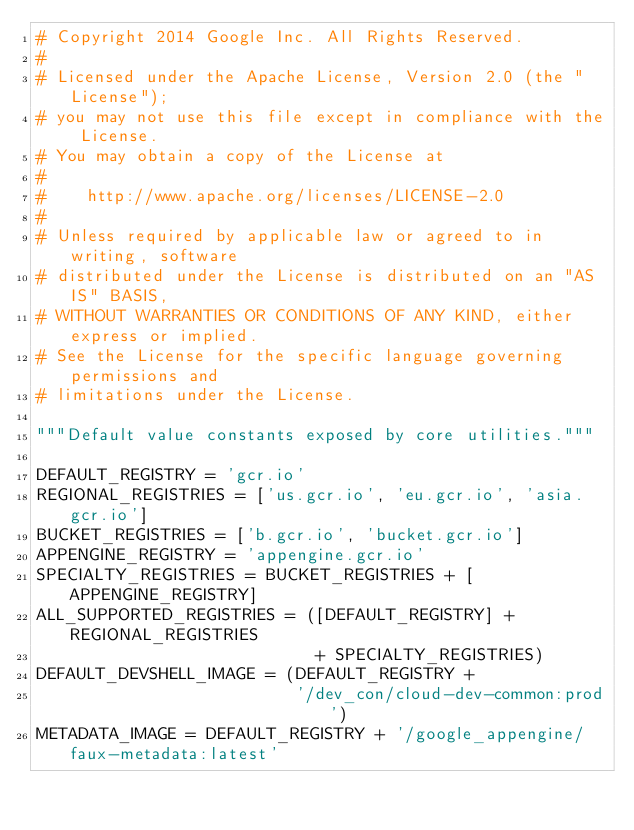<code> <loc_0><loc_0><loc_500><loc_500><_Python_># Copyright 2014 Google Inc. All Rights Reserved.
#
# Licensed under the Apache License, Version 2.0 (the "License");
# you may not use this file except in compliance with the License.
# You may obtain a copy of the License at
#
#    http://www.apache.org/licenses/LICENSE-2.0
#
# Unless required by applicable law or agreed to in writing, software
# distributed under the License is distributed on an "AS IS" BASIS,
# WITHOUT WARRANTIES OR CONDITIONS OF ANY KIND, either express or implied.
# See the License for the specific language governing permissions and
# limitations under the License.

"""Default value constants exposed by core utilities."""

DEFAULT_REGISTRY = 'gcr.io'
REGIONAL_REGISTRIES = ['us.gcr.io', 'eu.gcr.io', 'asia.gcr.io']
BUCKET_REGISTRIES = ['b.gcr.io', 'bucket.gcr.io']
APPENGINE_REGISTRY = 'appengine.gcr.io'
SPECIALTY_REGISTRIES = BUCKET_REGISTRIES + [APPENGINE_REGISTRY]
ALL_SUPPORTED_REGISTRIES = ([DEFAULT_REGISTRY] + REGIONAL_REGISTRIES
                            + SPECIALTY_REGISTRIES)
DEFAULT_DEVSHELL_IMAGE = (DEFAULT_REGISTRY +
                          '/dev_con/cloud-dev-common:prod')
METADATA_IMAGE = DEFAULT_REGISTRY + '/google_appengine/faux-metadata:latest'
</code> 